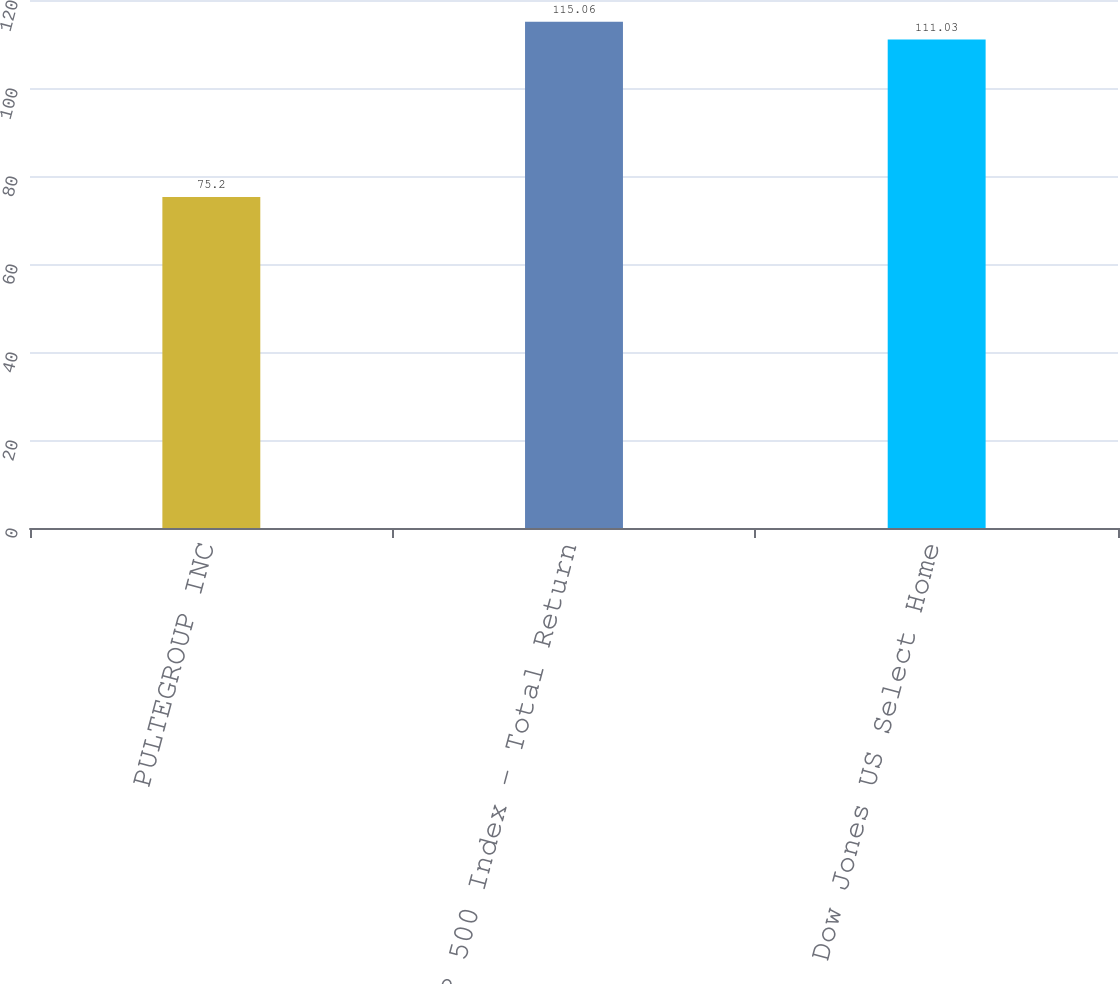Convert chart. <chart><loc_0><loc_0><loc_500><loc_500><bar_chart><fcel>PULTEGROUP INC<fcel>S&P 500 Index - Total Return<fcel>Dow Jones US Select Home<nl><fcel>75.2<fcel>115.06<fcel>111.03<nl></chart> 